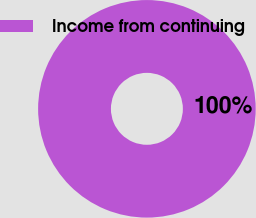Convert chart. <chart><loc_0><loc_0><loc_500><loc_500><pie_chart><fcel>Income from continuing<nl><fcel>100.0%<nl></chart> 